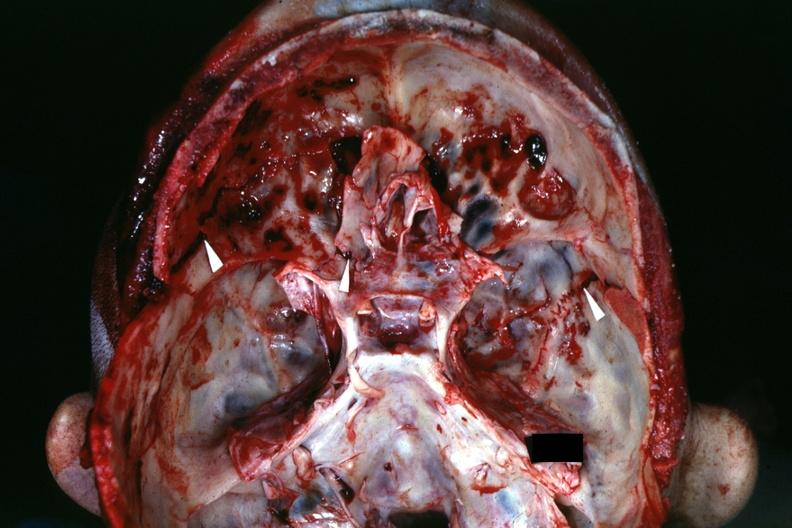s gangrene toe in infant present?
Answer the question using a single word or phrase. No 